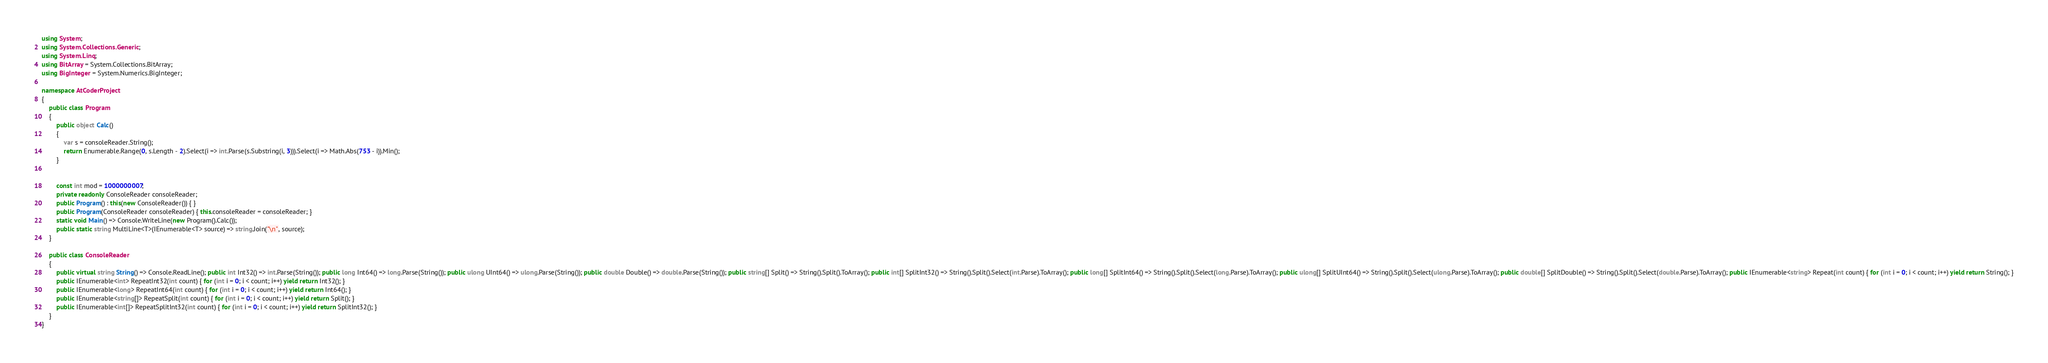Convert code to text. <code><loc_0><loc_0><loc_500><loc_500><_C#_>using System;
using System.Collections.Generic;
using System.Linq;
using BitArray = System.Collections.BitArray;
using BigInteger = System.Numerics.BigInteger;

namespace AtCoderProject
{
    public class Program
    {
        public object Calc()
        {
            var s = consoleReader.String();
            return Enumerable.Range(0, s.Length - 2).Select(i => int.Parse(s.Substring(i, 3))).Select(i => Math.Abs(753 - i)).Min();
        }


        const int mod = 1000000007;
        private readonly ConsoleReader consoleReader;
        public Program() : this(new ConsoleReader()) { }
        public Program(ConsoleReader consoleReader) { this.consoleReader = consoleReader; }
        static void Main() => Console.WriteLine(new Program().Calc());
        public static string MultiLine<T>(IEnumerable<T> source) => string.Join("\n", source);
    }

    public class ConsoleReader
    {
        public virtual string String() => Console.ReadLine(); public int Int32() => int.Parse(String()); public long Int64() => long.Parse(String()); public ulong UInt64() => ulong.Parse(String()); public double Double() => double.Parse(String()); public string[] Split() => String().Split().ToArray(); public int[] SplitInt32() => String().Split().Select(int.Parse).ToArray(); public long[] SplitInt64() => String().Split().Select(long.Parse).ToArray(); public ulong[] SplitUInt64() => String().Split().Select(ulong.Parse).ToArray(); public double[] SplitDouble() => String().Split().Select(double.Parse).ToArray(); public IEnumerable<string> Repeat(int count) { for (int i = 0; i < count; i++) yield return String(); }
        public IEnumerable<int> RepeatInt32(int count) { for (int i = 0; i < count; i++) yield return Int32(); }
        public IEnumerable<long> RepeatInt64(int count) { for (int i = 0; i < count; i++) yield return Int64(); }
        public IEnumerable<string[]> RepeatSplit(int count) { for (int i = 0; i < count; i++) yield return Split(); }
        public IEnumerable<int[]> RepeatSplitInt32(int count) { for (int i = 0; i < count; i++) yield return SplitInt32(); }
    }
}
</code> 